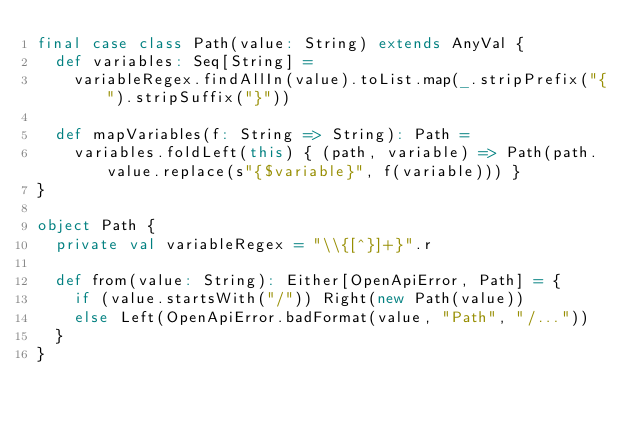<code> <loc_0><loc_0><loc_500><loc_500><_Scala_>final case class Path(value: String) extends AnyVal {
  def variables: Seq[String] =
    variableRegex.findAllIn(value).toList.map(_.stripPrefix("{").stripSuffix("}"))

  def mapVariables(f: String => String): Path =
    variables.foldLeft(this) { (path, variable) => Path(path.value.replace(s"{$variable}", f(variable))) }
}

object Path {
  private val variableRegex = "\\{[^}]+}".r

  def from(value: String): Either[OpenApiError, Path] = {
    if (value.startsWith("/")) Right(new Path(value))
    else Left(OpenApiError.badFormat(value, "Path", "/..."))
  }
}
</code> 